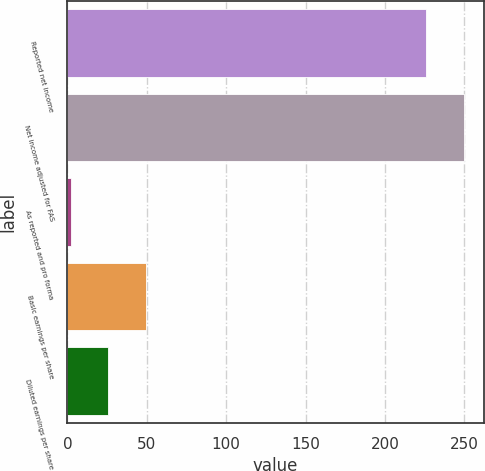<chart> <loc_0><loc_0><loc_500><loc_500><bar_chart><fcel>Reported net income<fcel>Net income adjusted for FAS<fcel>As reported and pro forma<fcel>Basic earnings per share<fcel>Diluted earnings per share<nl><fcel>226<fcel>249.63<fcel>2.19<fcel>49.45<fcel>25.82<nl></chart> 